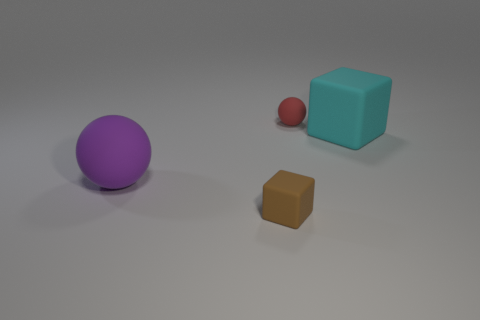What material is the brown object that is the same size as the red ball?
Ensure brevity in your answer.  Rubber. What number of other things are there of the same size as the purple rubber sphere?
Offer a terse response. 1. What number of cubes are cyan objects or big shiny objects?
Offer a terse response. 1. There is a block behind the rubber thing that is in front of the matte ball on the left side of the brown matte object; what is its material?
Offer a terse response. Rubber. How many big cubes have the same material as the big purple ball?
Your answer should be very brief. 1. Is the size of the ball to the right of the purple rubber thing the same as the small rubber block?
Give a very brief answer. Yes. There is another big object that is the same material as the cyan object; what color is it?
Offer a terse response. Purple. Is there anything else that is the same size as the red rubber thing?
Your answer should be very brief. Yes. There is a tiny red sphere; how many cyan matte objects are to the left of it?
Provide a succinct answer. 0. Does the tiny matte thing that is behind the small rubber block have the same color as the large rubber object to the left of the big cyan matte cube?
Your answer should be very brief. No. 